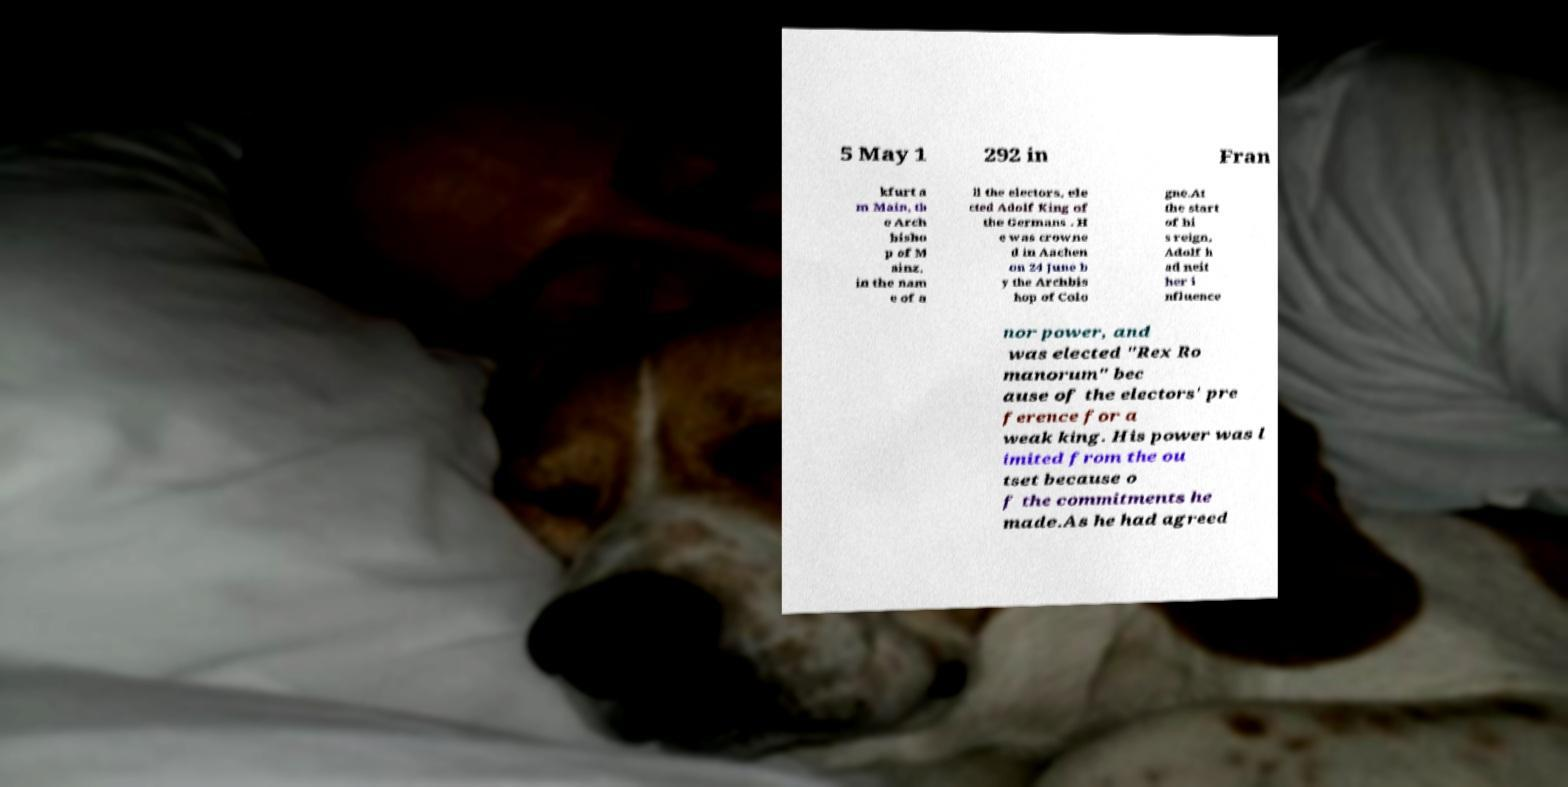What messages or text are displayed in this image? I need them in a readable, typed format. 5 May 1 292 in Fran kfurt a m Main, th e Arch bisho p of M ainz, in the nam e of a ll the electors, ele cted Adolf King of the Germans . H e was crowne d in Aachen on 24 June b y the Archbis hop of Colo gne.At the start of hi s reign, Adolf h ad neit her i nfluence nor power, and was elected "Rex Ro manorum" bec ause of the electors' pre ference for a weak king. His power was l imited from the ou tset because o f the commitments he made.As he had agreed 